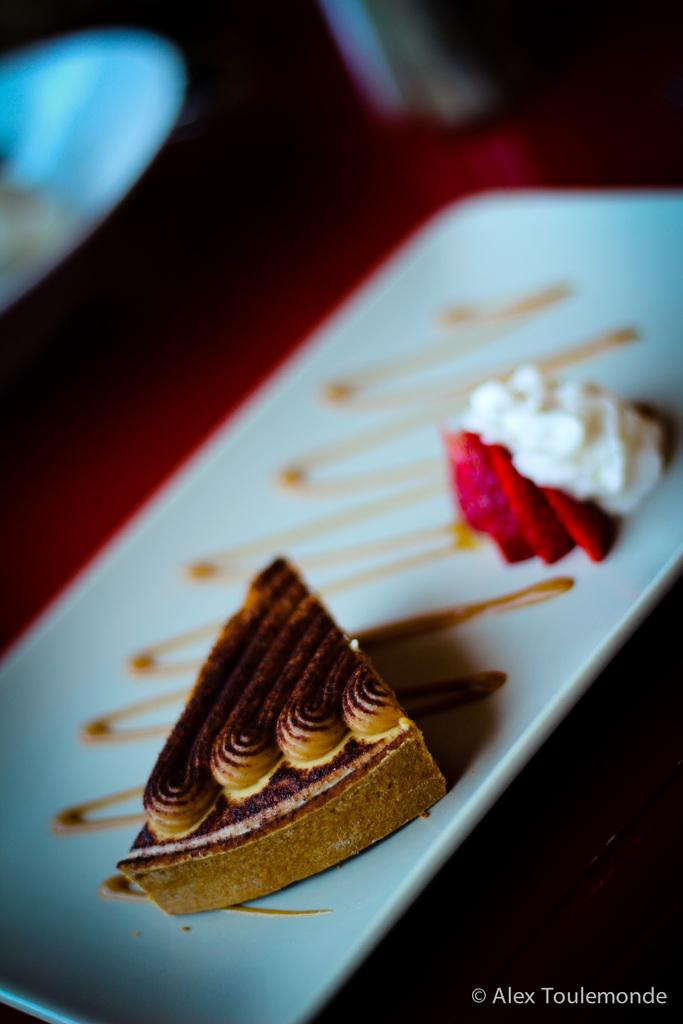What is present on the tray in the image? The tray contains cream and food. What can be observed about the background of the image? The background of the image is dark. Is there any additional detail visible in the image? Yes, there is a water mark in the bottom right side of the image. What type of attraction can be seen in the background of the image? There is no attraction visible in the image; the background is dark. How many sisters are present in the image? There are no sisters present in the image. 